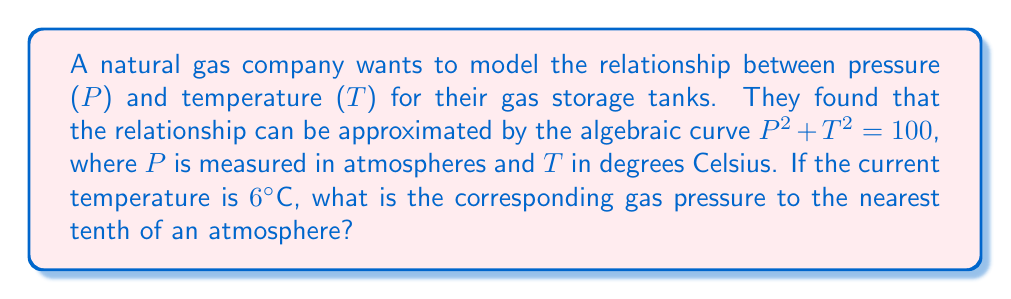Help me with this question. 1) The relationship between pressure (P) and temperature (T) is given by the equation:
   $$P^2 + T^2 = 100$$

2) We are given that the current temperature is 6°C. Let's substitute this into our equation:
   $$P^2 + 6^2 = 100$$

3) Simplify:
   $$P^2 + 36 = 100$$

4) Subtract 36 from both sides:
   $$P^2 = 64$$

5) Take the square root of both sides:
   $$P = \pm 8$$

6) Since pressure cannot be negative in this context, we take the positive value:
   $$P = 8$$

7) The question asks for the answer to the nearest tenth, but 8 is already in that form, so no further rounding is necessary.
Answer: 8.0 atmospheres 